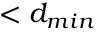<formula> <loc_0><loc_0><loc_500><loc_500>< d _ { \min }</formula> 